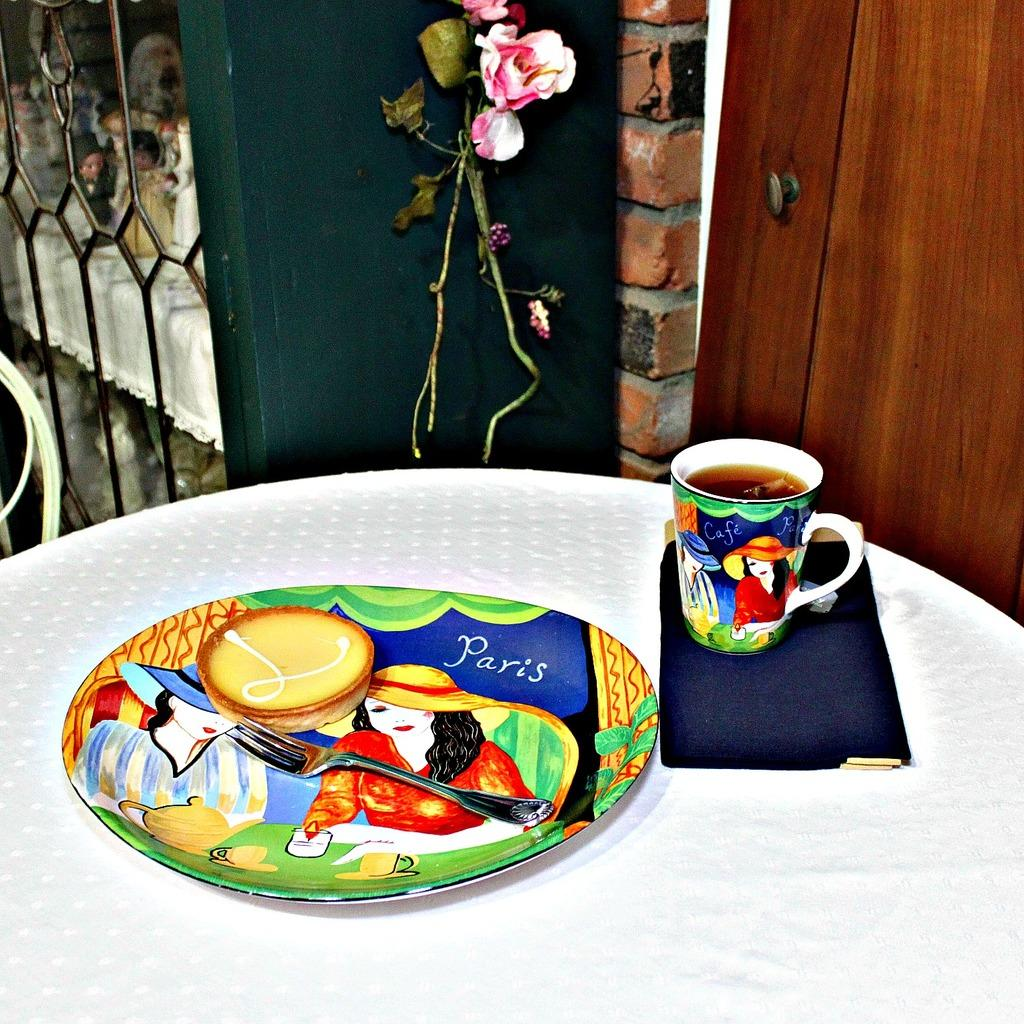What is on the plate that is visible in the image? The plate contains a cookie. What utensil is on the plate in the image? There is a fork on the plate. What is on the table in the image? There is a cup on the table. What type of flowers can be seen at the top of the image? Rose flowers are visible at the top of the image. What type of mark can be seen on the cookie in the image? There is no mark visible on the cookie in the image. Can you tell me how many acres of land are depicted in the image? There is no land present in the image; it features a plate with a cookie, a fork, a cup, and rose flowers. 